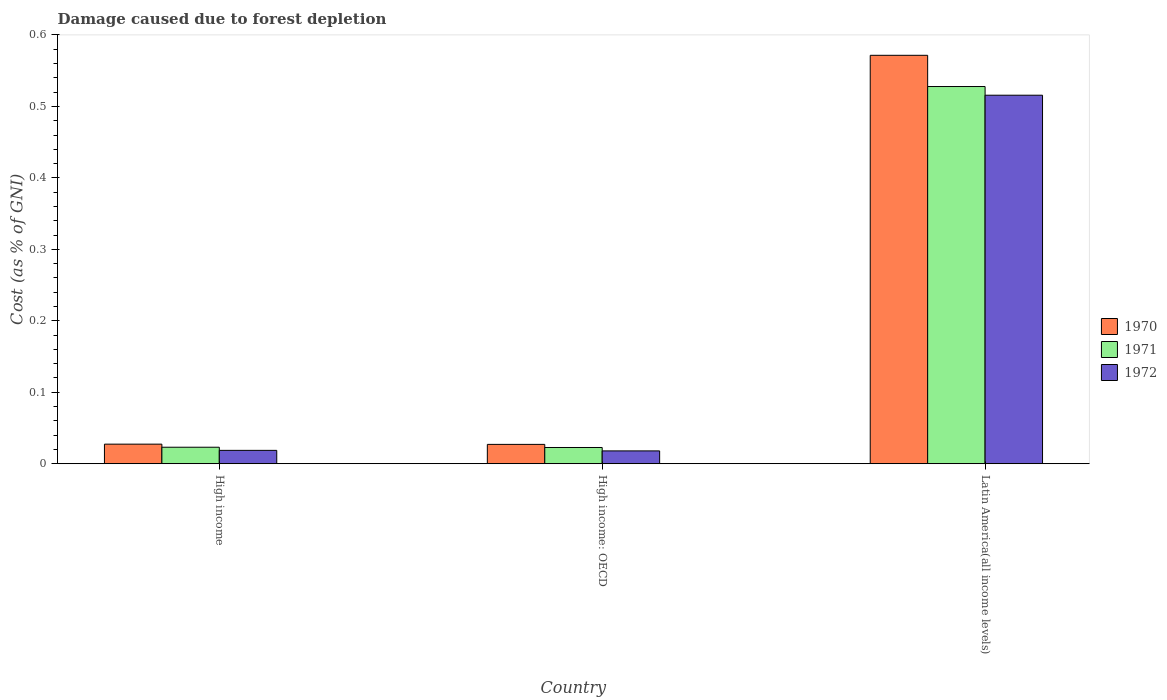How many groups of bars are there?
Your answer should be compact. 3. How many bars are there on the 3rd tick from the left?
Provide a succinct answer. 3. How many bars are there on the 2nd tick from the right?
Provide a succinct answer. 3. What is the label of the 3rd group of bars from the left?
Keep it short and to the point. Latin America(all income levels). What is the cost of damage caused due to forest depletion in 1970 in High income?
Keep it short and to the point. 0.03. Across all countries, what is the maximum cost of damage caused due to forest depletion in 1970?
Offer a very short reply. 0.57. Across all countries, what is the minimum cost of damage caused due to forest depletion in 1972?
Give a very brief answer. 0.02. In which country was the cost of damage caused due to forest depletion in 1971 maximum?
Your response must be concise. Latin America(all income levels). In which country was the cost of damage caused due to forest depletion in 1972 minimum?
Offer a terse response. High income: OECD. What is the total cost of damage caused due to forest depletion in 1972 in the graph?
Offer a terse response. 0.55. What is the difference between the cost of damage caused due to forest depletion in 1972 in High income: OECD and that in Latin America(all income levels)?
Provide a succinct answer. -0.5. What is the difference between the cost of damage caused due to forest depletion in 1972 in Latin America(all income levels) and the cost of damage caused due to forest depletion in 1970 in High income?
Offer a very short reply. 0.49. What is the average cost of damage caused due to forest depletion in 1972 per country?
Give a very brief answer. 0.18. What is the difference between the cost of damage caused due to forest depletion of/in 1972 and cost of damage caused due to forest depletion of/in 1970 in High income?
Your response must be concise. -0.01. In how many countries, is the cost of damage caused due to forest depletion in 1972 greater than 0.44 %?
Make the answer very short. 1. What is the ratio of the cost of damage caused due to forest depletion in 1970 in High income: OECD to that in Latin America(all income levels)?
Keep it short and to the point. 0.05. Is the cost of damage caused due to forest depletion in 1970 in High income: OECD less than that in Latin America(all income levels)?
Your answer should be very brief. Yes. What is the difference between the highest and the second highest cost of damage caused due to forest depletion in 1970?
Your response must be concise. 0.54. What is the difference between the highest and the lowest cost of damage caused due to forest depletion in 1971?
Give a very brief answer. 0.51. In how many countries, is the cost of damage caused due to forest depletion in 1970 greater than the average cost of damage caused due to forest depletion in 1970 taken over all countries?
Your answer should be very brief. 1. Is the sum of the cost of damage caused due to forest depletion in 1970 in High income and Latin America(all income levels) greater than the maximum cost of damage caused due to forest depletion in 1972 across all countries?
Provide a succinct answer. Yes. What does the 3rd bar from the right in High income: OECD represents?
Provide a short and direct response. 1970. How many countries are there in the graph?
Ensure brevity in your answer.  3. Are the values on the major ticks of Y-axis written in scientific E-notation?
Your answer should be compact. No. Does the graph contain any zero values?
Your response must be concise. No. How are the legend labels stacked?
Offer a very short reply. Vertical. What is the title of the graph?
Your answer should be compact. Damage caused due to forest depletion. What is the label or title of the X-axis?
Keep it short and to the point. Country. What is the label or title of the Y-axis?
Offer a terse response. Cost (as % of GNI). What is the Cost (as % of GNI) of 1970 in High income?
Keep it short and to the point. 0.03. What is the Cost (as % of GNI) of 1971 in High income?
Your answer should be compact. 0.02. What is the Cost (as % of GNI) in 1972 in High income?
Offer a very short reply. 0.02. What is the Cost (as % of GNI) of 1970 in High income: OECD?
Give a very brief answer. 0.03. What is the Cost (as % of GNI) of 1971 in High income: OECD?
Provide a short and direct response. 0.02. What is the Cost (as % of GNI) in 1972 in High income: OECD?
Your answer should be very brief. 0.02. What is the Cost (as % of GNI) of 1970 in Latin America(all income levels)?
Ensure brevity in your answer.  0.57. What is the Cost (as % of GNI) in 1971 in Latin America(all income levels)?
Keep it short and to the point. 0.53. What is the Cost (as % of GNI) of 1972 in Latin America(all income levels)?
Ensure brevity in your answer.  0.52. Across all countries, what is the maximum Cost (as % of GNI) in 1970?
Your answer should be very brief. 0.57. Across all countries, what is the maximum Cost (as % of GNI) of 1971?
Provide a succinct answer. 0.53. Across all countries, what is the maximum Cost (as % of GNI) in 1972?
Keep it short and to the point. 0.52. Across all countries, what is the minimum Cost (as % of GNI) in 1970?
Offer a very short reply. 0.03. Across all countries, what is the minimum Cost (as % of GNI) of 1971?
Your answer should be very brief. 0.02. Across all countries, what is the minimum Cost (as % of GNI) of 1972?
Offer a terse response. 0.02. What is the total Cost (as % of GNI) of 1970 in the graph?
Your answer should be compact. 0.63. What is the total Cost (as % of GNI) of 1971 in the graph?
Provide a short and direct response. 0.57. What is the total Cost (as % of GNI) in 1972 in the graph?
Provide a short and direct response. 0.55. What is the difference between the Cost (as % of GNI) in 1972 in High income and that in High income: OECD?
Offer a terse response. 0. What is the difference between the Cost (as % of GNI) in 1970 in High income and that in Latin America(all income levels)?
Your answer should be very brief. -0.54. What is the difference between the Cost (as % of GNI) of 1971 in High income and that in Latin America(all income levels)?
Your answer should be compact. -0.5. What is the difference between the Cost (as % of GNI) in 1972 in High income and that in Latin America(all income levels)?
Give a very brief answer. -0.5. What is the difference between the Cost (as % of GNI) in 1970 in High income: OECD and that in Latin America(all income levels)?
Provide a succinct answer. -0.54. What is the difference between the Cost (as % of GNI) in 1971 in High income: OECD and that in Latin America(all income levels)?
Give a very brief answer. -0.51. What is the difference between the Cost (as % of GNI) of 1972 in High income: OECD and that in Latin America(all income levels)?
Ensure brevity in your answer.  -0.5. What is the difference between the Cost (as % of GNI) of 1970 in High income and the Cost (as % of GNI) of 1971 in High income: OECD?
Provide a short and direct response. 0. What is the difference between the Cost (as % of GNI) in 1970 in High income and the Cost (as % of GNI) in 1972 in High income: OECD?
Your answer should be compact. 0.01. What is the difference between the Cost (as % of GNI) of 1971 in High income and the Cost (as % of GNI) of 1972 in High income: OECD?
Provide a short and direct response. 0.01. What is the difference between the Cost (as % of GNI) of 1970 in High income and the Cost (as % of GNI) of 1971 in Latin America(all income levels)?
Provide a succinct answer. -0.5. What is the difference between the Cost (as % of GNI) of 1970 in High income and the Cost (as % of GNI) of 1972 in Latin America(all income levels)?
Ensure brevity in your answer.  -0.49. What is the difference between the Cost (as % of GNI) of 1971 in High income and the Cost (as % of GNI) of 1972 in Latin America(all income levels)?
Provide a succinct answer. -0.49. What is the difference between the Cost (as % of GNI) of 1970 in High income: OECD and the Cost (as % of GNI) of 1971 in Latin America(all income levels)?
Provide a succinct answer. -0.5. What is the difference between the Cost (as % of GNI) of 1970 in High income: OECD and the Cost (as % of GNI) of 1972 in Latin America(all income levels)?
Your response must be concise. -0.49. What is the difference between the Cost (as % of GNI) of 1971 in High income: OECD and the Cost (as % of GNI) of 1972 in Latin America(all income levels)?
Provide a succinct answer. -0.49. What is the average Cost (as % of GNI) of 1970 per country?
Your response must be concise. 0.21. What is the average Cost (as % of GNI) in 1971 per country?
Your answer should be very brief. 0.19. What is the average Cost (as % of GNI) of 1972 per country?
Provide a short and direct response. 0.18. What is the difference between the Cost (as % of GNI) in 1970 and Cost (as % of GNI) in 1971 in High income?
Offer a terse response. 0. What is the difference between the Cost (as % of GNI) in 1970 and Cost (as % of GNI) in 1972 in High income?
Make the answer very short. 0.01. What is the difference between the Cost (as % of GNI) in 1971 and Cost (as % of GNI) in 1972 in High income?
Your answer should be very brief. 0. What is the difference between the Cost (as % of GNI) of 1970 and Cost (as % of GNI) of 1971 in High income: OECD?
Offer a very short reply. 0. What is the difference between the Cost (as % of GNI) in 1970 and Cost (as % of GNI) in 1972 in High income: OECD?
Keep it short and to the point. 0.01. What is the difference between the Cost (as % of GNI) in 1971 and Cost (as % of GNI) in 1972 in High income: OECD?
Make the answer very short. 0. What is the difference between the Cost (as % of GNI) of 1970 and Cost (as % of GNI) of 1971 in Latin America(all income levels)?
Your answer should be compact. 0.04. What is the difference between the Cost (as % of GNI) of 1970 and Cost (as % of GNI) of 1972 in Latin America(all income levels)?
Keep it short and to the point. 0.06. What is the difference between the Cost (as % of GNI) of 1971 and Cost (as % of GNI) of 1972 in Latin America(all income levels)?
Your response must be concise. 0.01. What is the ratio of the Cost (as % of GNI) of 1971 in High income to that in High income: OECD?
Your answer should be compact. 1.02. What is the ratio of the Cost (as % of GNI) in 1972 in High income to that in High income: OECD?
Give a very brief answer. 1.04. What is the ratio of the Cost (as % of GNI) of 1970 in High income to that in Latin America(all income levels)?
Your response must be concise. 0.05. What is the ratio of the Cost (as % of GNI) in 1971 in High income to that in Latin America(all income levels)?
Your answer should be very brief. 0.04. What is the ratio of the Cost (as % of GNI) of 1972 in High income to that in Latin America(all income levels)?
Make the answer very short. 0.04. What is the ratio of the Cost (as % of GNI) of 1970 in High income: OECD to that in Latin America(all income levels)?
Provide a succinct answer. 0.05. What is the ratio of the Cost (as % of GNI) in 1971 in High income: OECD to that in Latin America(all income levels)?
Give a very brief answer. 0.04. What is the ratio of the Cost (as % of GNI) of 1972 in High income: OECD to that in Latin America(all income levels)?
Give a very brief answer. 0.03. What is the difference between the highest and the second highest Cost (as % of GNI) of 1970?
Ensure brevity in your answer.  0.54. What is the difference between the highest and the second highest Cost (as % of GNI) in 1971?
Offer a very short reply. 0.5. What is the difference between the highest and the second highest Cost (as % of GNI) in 1972?
Your response must be concise. 0.5. What is the difference between the highest and the lowest Cost (as % of GNI) in 1970?
Your answer should be compact. 0.54. What is the difference between the highest and the lowest Cost (as % of GNI) of 1971?
Your answer should be compact. 0.51. What is the difference between the highest and the lowest Cost (as % of GNI) of 1972?
Provide a short and direct response. 0.5. 